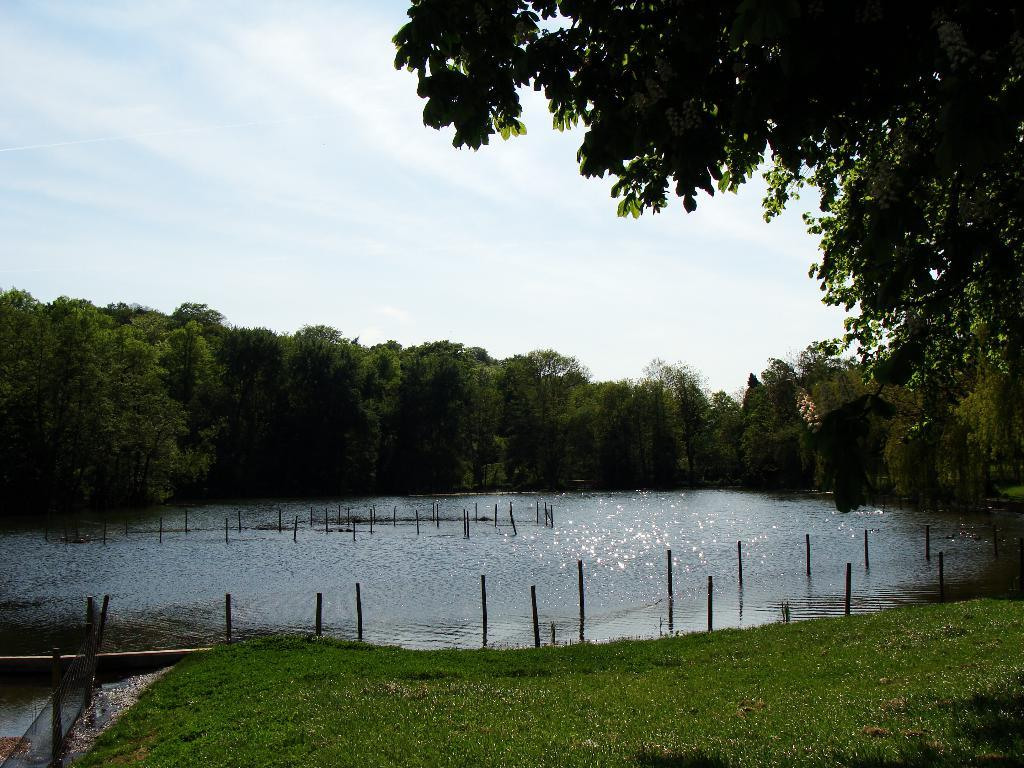What type of vegetation is in the foreground of the image? There is grass in the foreground of the image. What is located behind the grass? There is a water surface behind the grass. What can be seen in the distance in the image? There are trees in the background of the image. What type of pan is visible in the image? There is no pan present in the image. What kind of creature can be seen swimming in the water surface? There is no creature visible in the image; it only shows grass, water surface, and trees. 